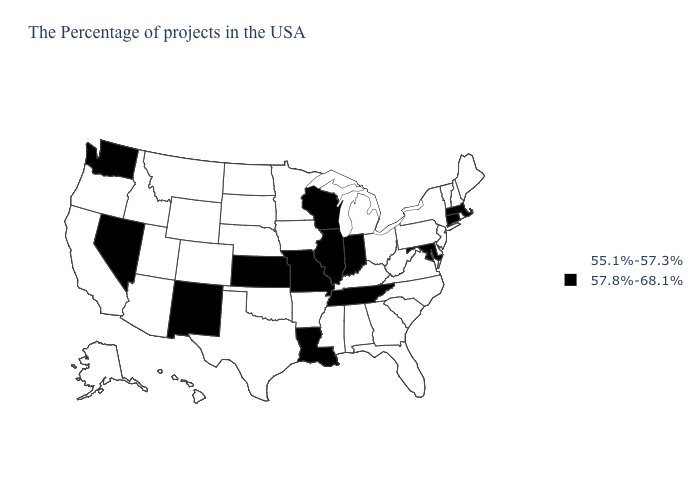Among the states that border South Carolina , which have the lowest value?
Short answer required. North Carolina, Georgia. What is the highest value in the USA?
Give a very brief answer. 57.8%-68.1%. What is the value of North Carolina?
Short answer required. 55.1%-57.3%. What is the highest value in states that border Tennessee?
Short answer required. 57.8%-68.1%. Among the states that border Mississippi , which have the highest value?
Concise answer only. Tennessee, Louisiana. What is the value of North Carolina?
Give a very brief answer. 55.1%-57.3%. What is the value of Hawaii?
Be succinct. 55.1%-57.3%. What is the value of Vermont?
Write a very short answer. 55.1%-57.3%. Among the states that border West Virginia , does Ohio have the lowest value?
Write a very short answer. Yes. Name the states that have a value in the range 55.1%-57.3%?
Concise answer only. Maine, Rhode Island, New Hampshire, Vermont, New York, New Jersey, Delaware, Pennsylvania, Virginia, North Carolina, South Carolina, West Virginia, Ohio, Florida, Georgia, Michigan, Kentucky, Alabama, Mississippi, Arkansas, Minnesota, Iowa, Nebraska, Oklahoma, Texas, South Dakota, North Dakota, Wyoming, Colorado, Utah, Montana, Arizona, Idaho, California, Oregon, Alaska, Hawaii. Which states have the lowest value in the USA?
Give a very brief answer. Maine, Rhode Island, New Hampshire, Vermont, New York, New Jersey, Delaware, Pennsylvania, Virginia, North Carolina, South Carolina, West Virginia, Ohio, Florida, Georgia, Michigan, Kentucky, Alabama, Mississippi, Arkansas, Minnesota, Iowa, Nebraska, Oklahoma, Texas, South Dakota, North Dakota, Wyoming, Colorado, Utah, Montana, Arizona, Idaho, California, Oregon, Alaska, Hawaii. Among the states that border Georgia , does Tennessee have the lowest value?
Short answer required. No. What is the value of Virginia?
Short answer required. 55.1%-57.3%. Does the map have missing data?
Write a very short answer. No. Name the states that have a value in the range 55.1%-57.3%?
Quick response, please. Maine, Rhode Island, New Hampshire, Vermont, New York, New Jersey, Delaware, Pennsylvania, Virginia, North Carolina, South Carolina, West Virginia, Ohio, Florida, Georgia, Michigan, Kentucky, Alabama, Mississippi, Arkansas, Minnesota, Iowa, Nebraska, Oklahoma, Texas, South Dakota, North Dakota, Wyoming, Colorado, Utah, Montana, Arizona, Idaho, California, Oregon, Alaska, Hawaii. 